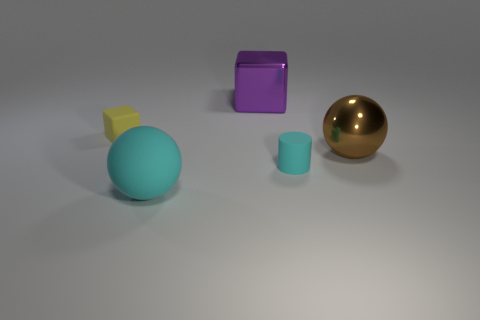There is a rubber thing that is both to the left of the big purple metal cube and right of the yellow block; what is its shape?
Ensure brevity in your answer.  Sphere. There is a big matte thing; are there any rubber objects on the right side of it?
Offer a very short reply. Yes. Is there any other thing that is the same shape as the large brown object?
Your answer should be compact. Yes. Is the large rubber object the same shape as the large brown thing?
Provide a succinct answer. Yes. Is the number of tiny matte things in front of the large brown ball the same as the number of metal objects that are in front of the yellow matte object?
Your answer should be compact. Yes. How many other things are there of the same material as the big cube?
Your response must be concise. 1. How many big objects are yellow things or purple rubber spheres?
Ensure brevity in your answer.  0. Are there an equal number of purple blocks in front of the brown thing and large purple metallic cubes?
Offer a very short reply. No. There is a ball that is on the left side of the big brown metallic object; is there a tiny thing to the left of it?
Give a very brief answer. Yes. How many other things are there of the same color as the big matte thing?
Your answer should be compact. 1. 